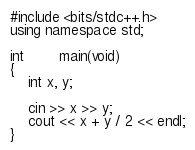<code> <loc_0><loc_0><loc_500><loc_500><_C++_>#include <bits/stdc++.h>
using namespace std;

int		main(void)
{
	int x, y;

	cin >> x >> y;
	cout << x + y / 2 << endl;
}
</code> 